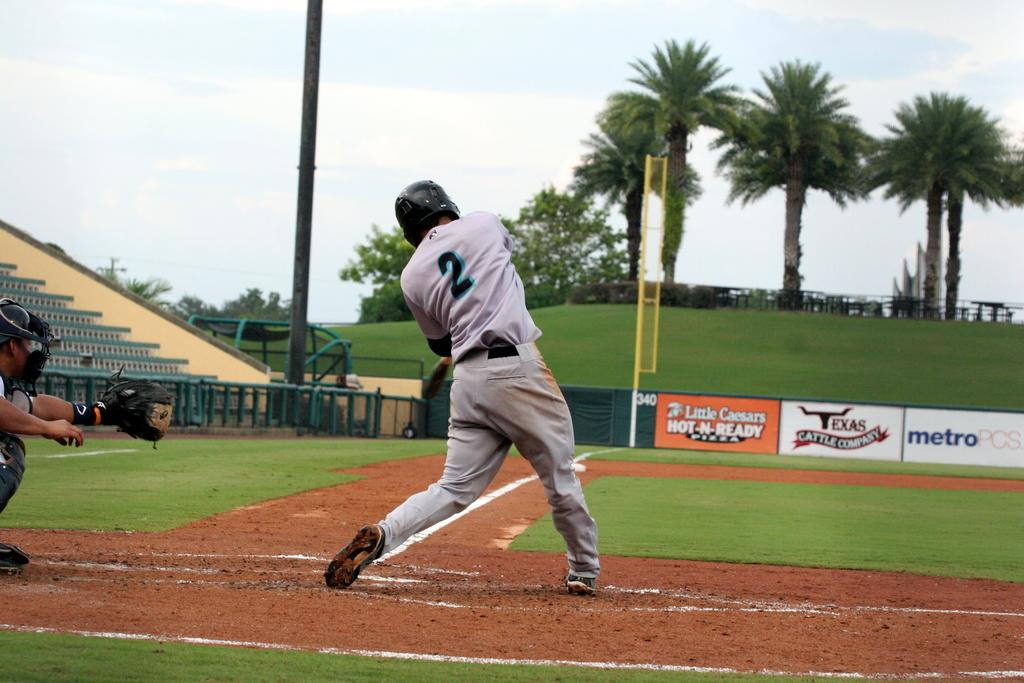<image>
Describe the image concisely. A baseball player swings his bat with an ad for Little Caesars in the background. 